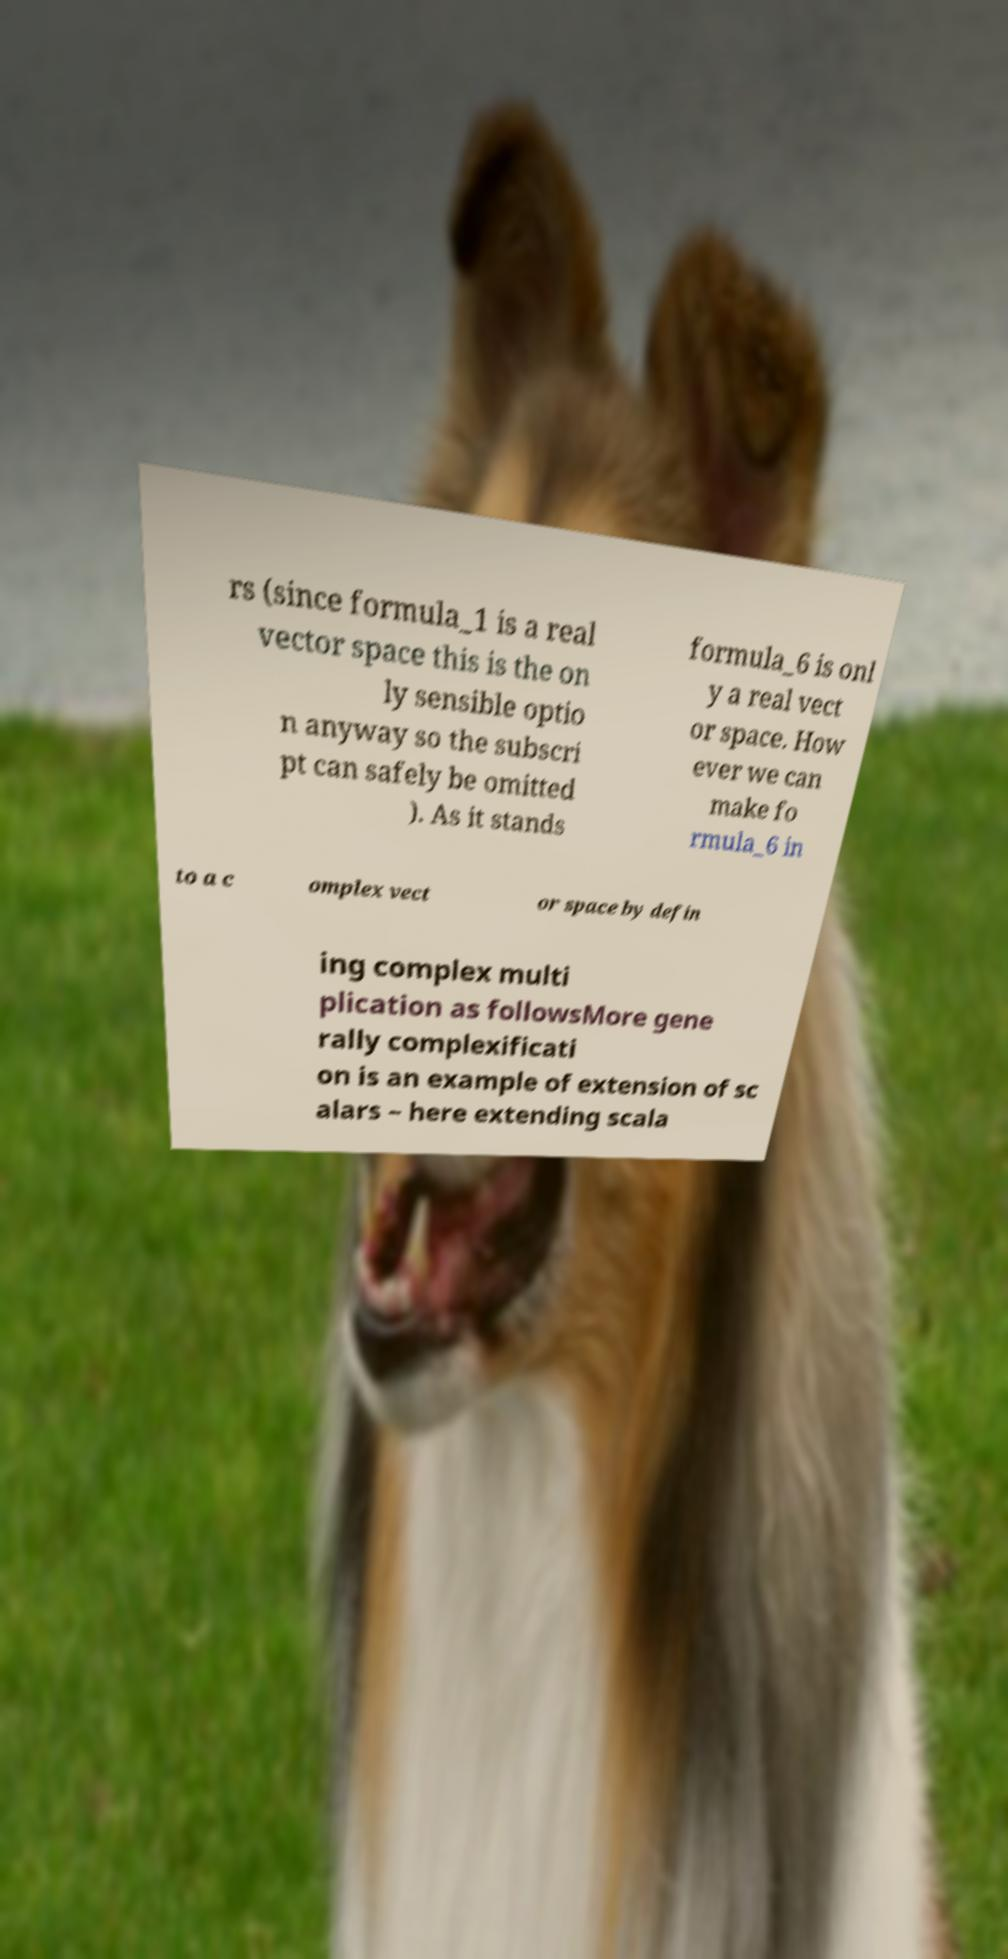Could you extract and type out the text from this image? rs (since formula_1 is a real vector space this is the on ly sensible optio n anyway so the subscri pt can safely be omitted ). As it stands formula_6 is onl y a real vect or space. How ever we can make fo rmula_6 in to a c omplex vect or space by defin ing complex multi plication as followsMore gene rally complexificati on is an example of extension of sc alars – here extending scala 